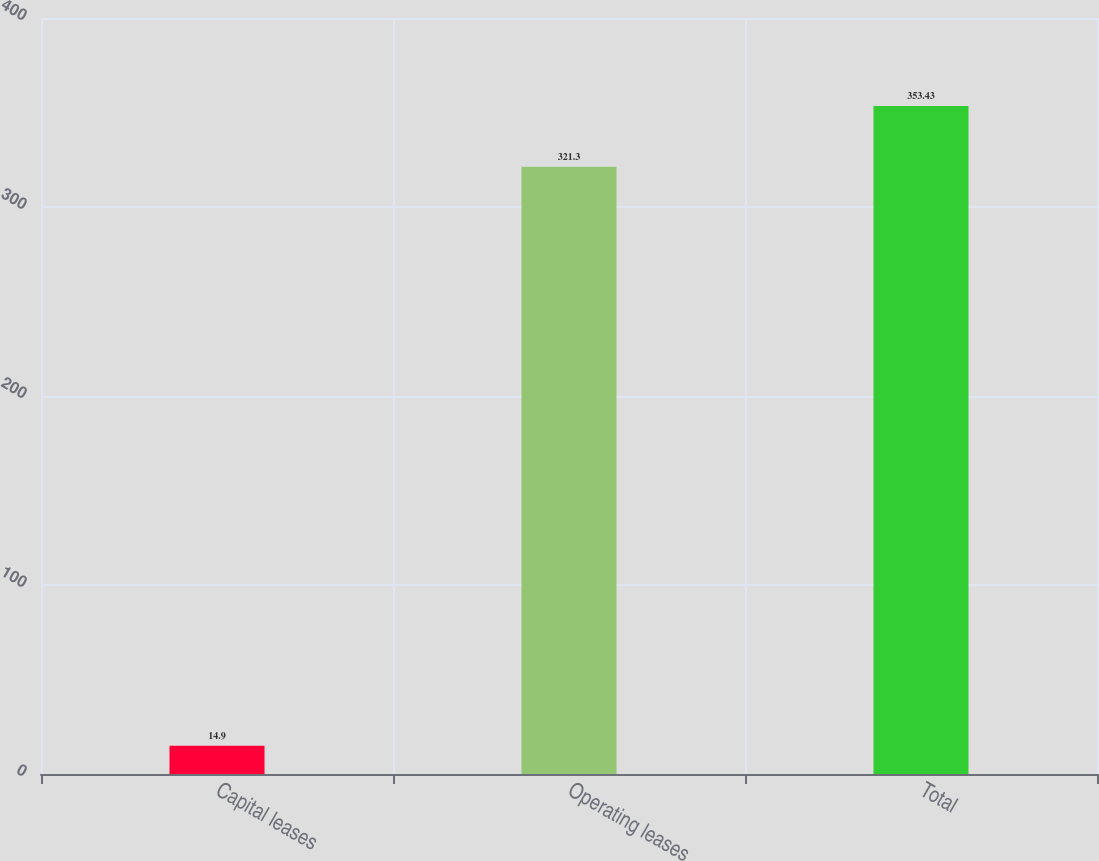<chart> <loc_0><loc_0><loc_500><loc_500><bar_chart><fcel>Capital leases<fcel>Operating leases<fcel>Total<nl><fcel>14.9<fcel>321.3<fcel>353.43<nl></chart> 